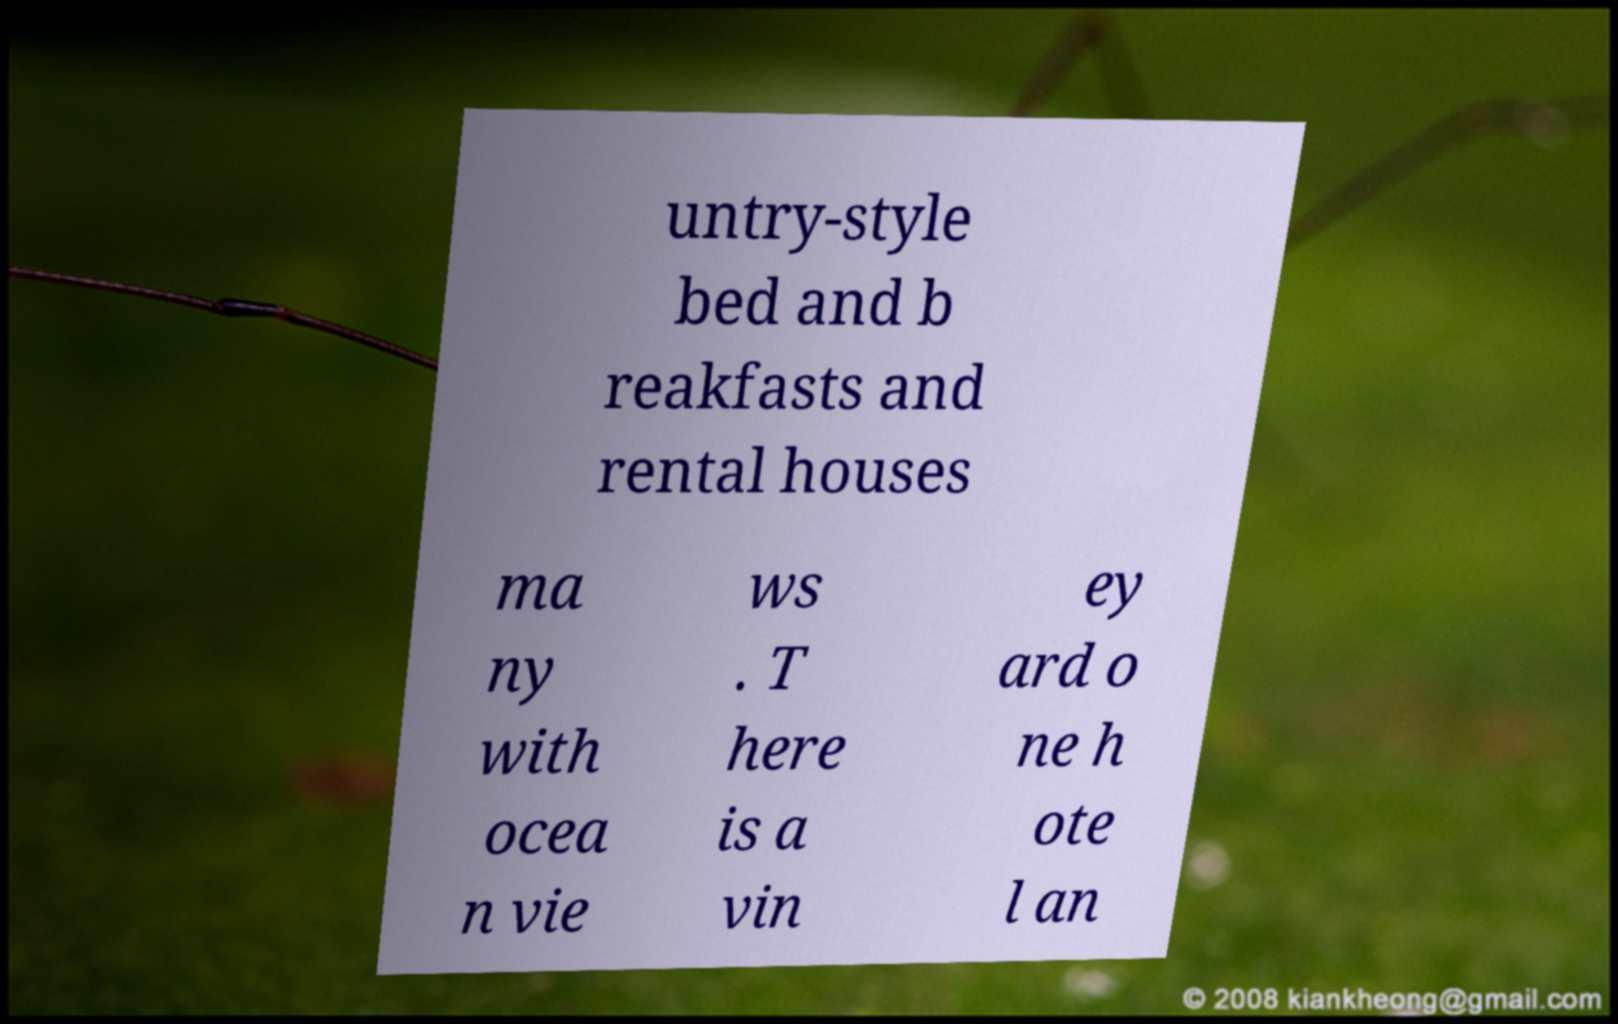Please read and relay the text visible in this image. What does it say? untry-style bed and b reakfasts and rental houses ma ny with ocea n vie ws . T here is a vin ey ard o ne h ote l an 